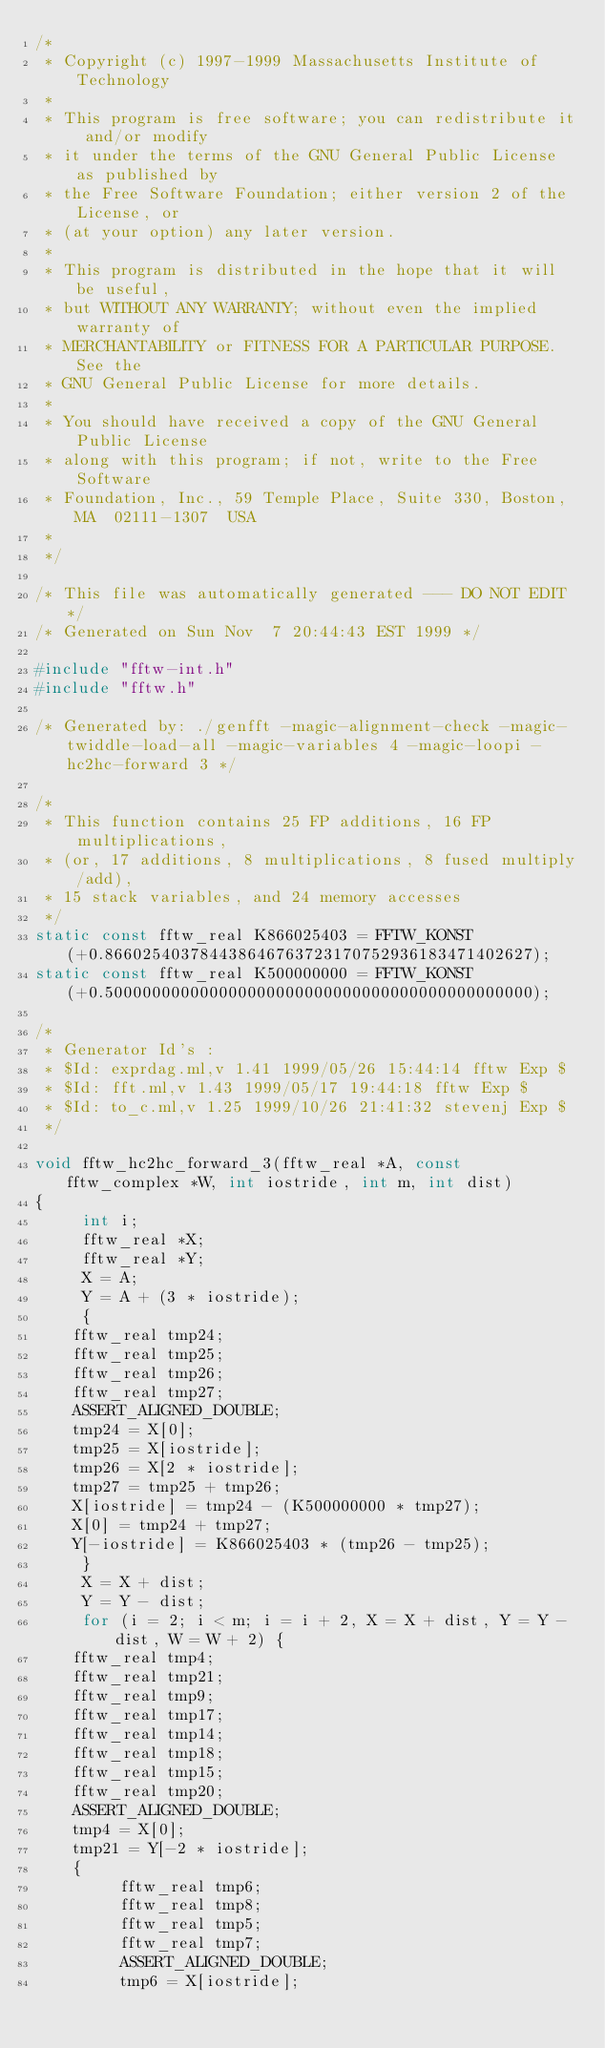<code> <loc_0><loc_0><loc_500><loc_500><_C_>/*
 * Copyright (c) 1997-1999 Massachusetts Institute of Technology
 *
 * This program is free software; you can redistribute it and/or modify
 * it under the terms of the GNU General Public License as published by
 * the Free Software Foundation; either version 2 of the License, or
 * (at your option) any later version.
 *
 * This program is distributed in the hope that it will be useful,
 * but WITHOUT ANY WARRANTY; without even the implied warranty of
 * MERCHANTABILITY or FITNESS FOR A PARTICULAR PURPOSE.  See the
 * GNU General Public License for more details.
 *
 * You should have received a copy of the GNU General Public License
 * along with this program; if not, write to the Free Software
 * Foundation, Inc., 59 Temple Place, Suite 330, Boston, MA  02111-1307  USA
 *
 */

/* This file was automatically generated --- DO NOT EDIT */
/* Generated on Sun Nov  7 20:44:43 EST 1999 */

#include "fftw-int.h"
#include "fftw.h"

/* Generated by: ./genfft -magic-alignment-check -magic-twiddle-load-all -magic-variables 4 -magic-loopi -hc2hc-forward 3 */

/*
 * This function contains 25 FP additions, 16 FP multiplications,
 * (or, 17 additions, 8 multiplications, 8 fused multiply/add),
 * 15 stack variables, and 24 memory accesses
 */
static const fftw_real K866025403 = FFTW_KONST(+0.866025403784438646763723170752936183471402627);
static const fftw_real K500000000 = FFTW_KONST(+0.500000000000000000000000000000000000000000000);

/*
 * Generator Id's : 
 * $Id: exprdag.ml,v 1.41 1999/05/26 15:44:14 fftw Exp $
 * $Id: fft.ml,v 1.43 1999/05/17 19:44:18 fftw Exp $
 * $Id: to_c.ml,v 1.25 1999/10/26 21:41:32 stevenj Exp $
 */

void fftw_hc2hc_forward_3(fftw_real *A, const fftw_complex *W, int iostride, int m, int dist)
{
     int i;
     fftw_real *X;
     fftw_real *Y;
     X = A;
     Y = A + (3 * iostride);
     {
	  fftw_real tmp24;
	  fftw_real tmp25;
	  fftw_real tmp26;
	  fftw_real tmp27;
	  ASSERT_ALIGNED_DOUBLE;
	  tmp24 = X[0];
	  tmp25 = X[iostride];
	  tmp26 = X[2 * iostride];
	  tmp27 = tmp25 + tmp26;
	  X[iostride] = tmp24 - (K500000000 * tmp27);
	  X[0] = tmp24 + tmp27;
	  Y[-iostride] = K866025403 * (tmp26 - tmp25);
     }
     X = X + dist;
     Y = Y - dist;
     for (i = 2; i < m; i = i + 2, X = X + dist, Y = Y - dist, W = W + 2) {
	  fftw_real tmp4;
	  fftw_real tmp21;
	  fftw_real tmp9;
	  fftw_real tmp17;
	  fftw_real tmp14;
	  fftw_real tmp18;
	  fftw_real tmp15;
	  fftw_real tmp20;
	  ASSERT_ALIGNED_DOUBLE;
	  tmp4 = X[0];
	  tmp21 = Y[-2 * iostride];
	  {
	       fftw_real tmp6;
	       fftw_real tmp8;
	       fftw_real tmp5;
	       fftw_real tmp7;
	       ASSERT_ALIGNED_DOUBLE;
	       tmp6 = X[iostride];</code> 